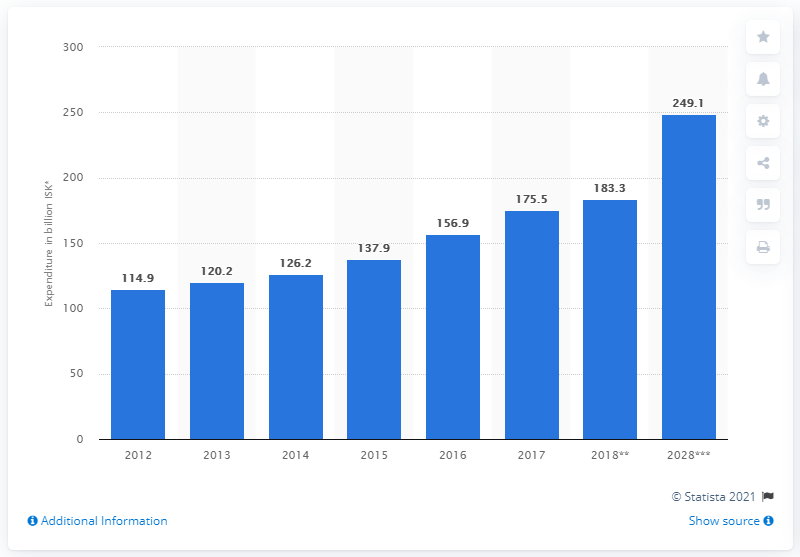Point out several critical features in this image. In 2018, an estimated amount of 183.3 million Icelandic krónur was spent on travel abroad by Icelanders. 